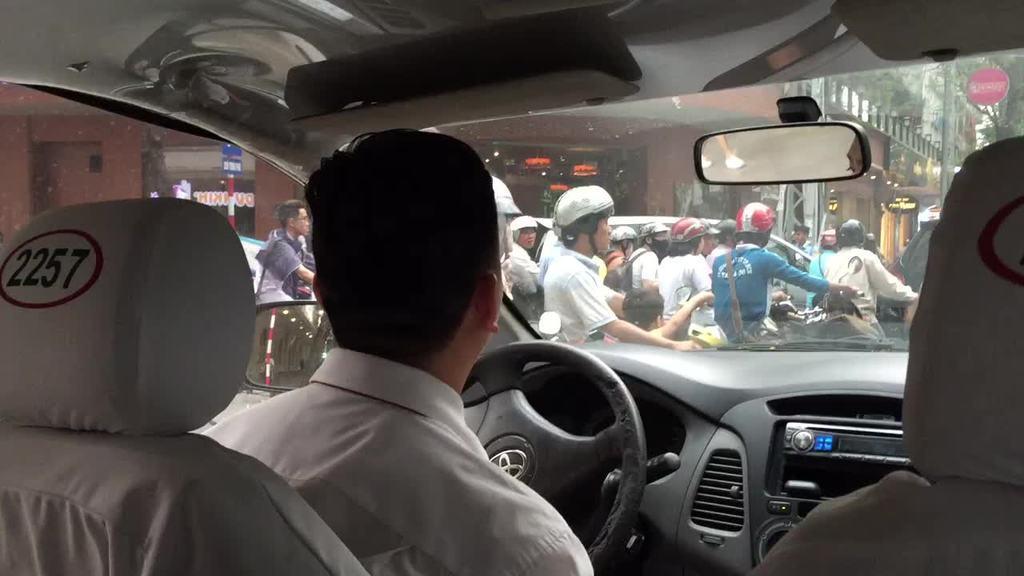Please provide a concise description of this image. The image is taken inside a car. A man is sitting in the driver seat, there are many people in front of car not of them are wearing helmet. There is a building in the background. 